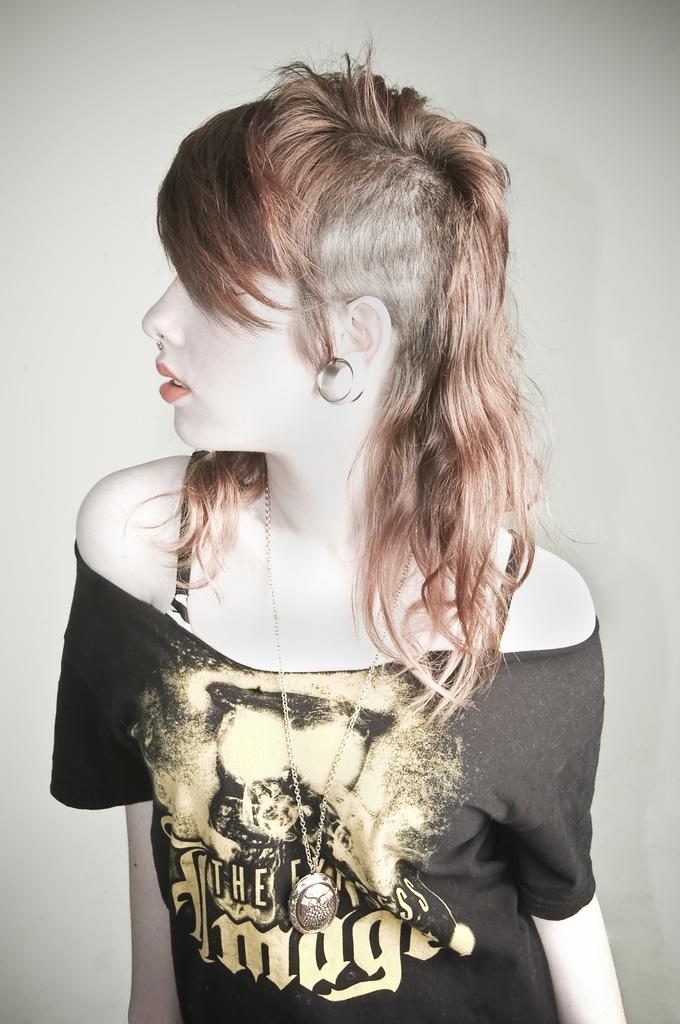What is the main subject of the image? There is a beautiful woman in the image. What is the woman wearing on her upper body? The woman is wearing a black t-shirt. Are there any accessories visible in the image? Yes, the woman is wearing a chain. How many zebras can be seen in the image? There are no zebras present in the image. What is the cause of death for the woman in the image? There is no indication of death in the image; the woman is alive and well. 